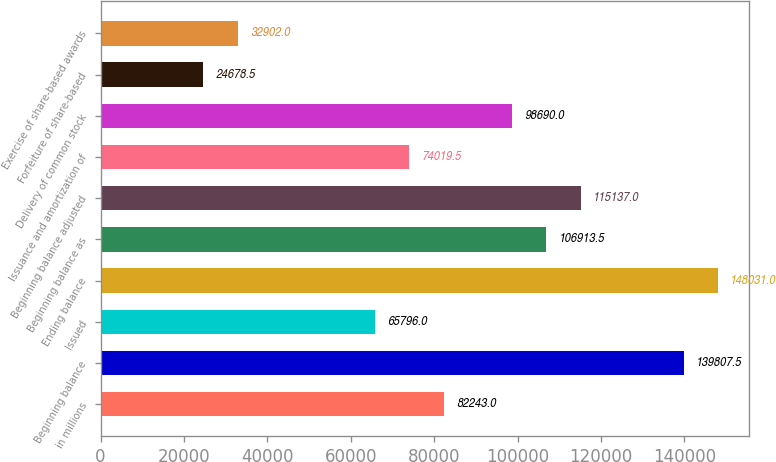Convert chart. <chart><loc_0><loc_0><loc_500><loc_500><bar_chart><fcel>in millions<fcel>Beginning balance<fcel>Issued<fcel>Ending balance<fcel>Beginning balance as<fcel>Beginning balance adjusted<fcel>Issuance and amortization of<fcel>Delivery of common stock<fcel>Forfeiture of share-based<fcel>Exercise of share-based awards<nl><fcel>82243<fcel>139808<fcel>65796<fcel>148031<fcel>106914<fcel>115137<fcel>74019.5<fcel>98690<fcel>24678.5<fcel>32902<nl></chart> 